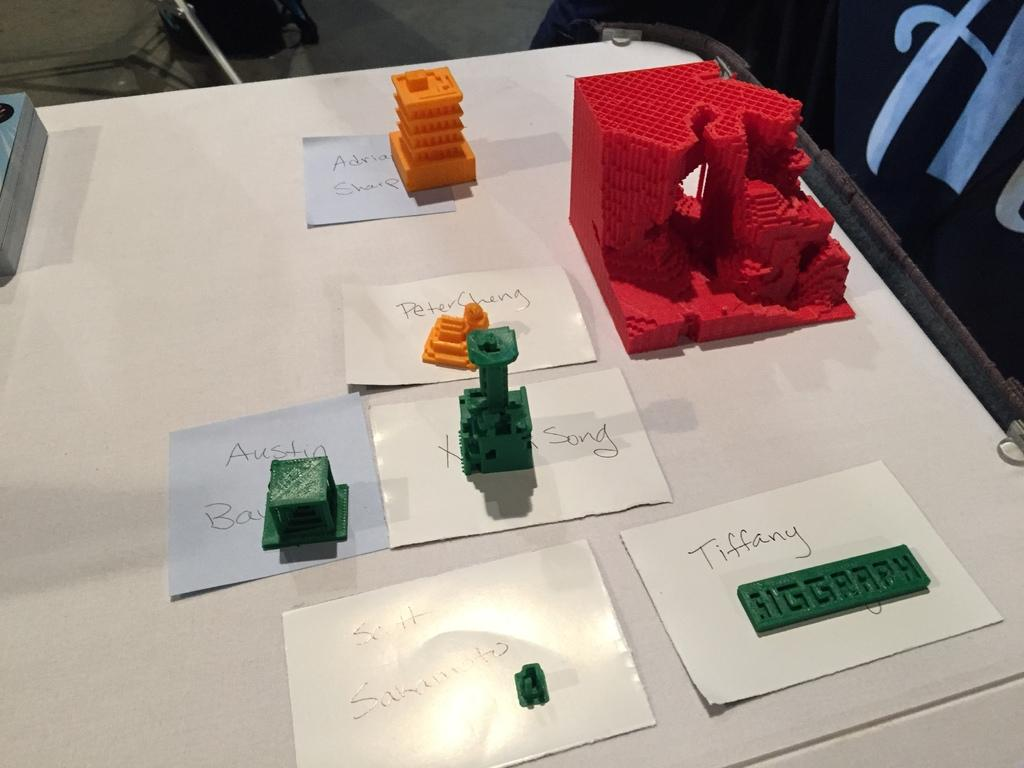What is on the table in the image? There are papers with text and plastic construction toys on the table. What might the papers with text be used for? The papers with text might be used for writing or reading. What type of toys are on the table? The toys on the table are plastic construction toys. What color is the dad's quiver in the image? There is no dad or quiver present in the image. What number is written on the plastic construction toy? The provided facts do not mention any numbers on the plastic construction toys, so it cannot be determined from the image. 